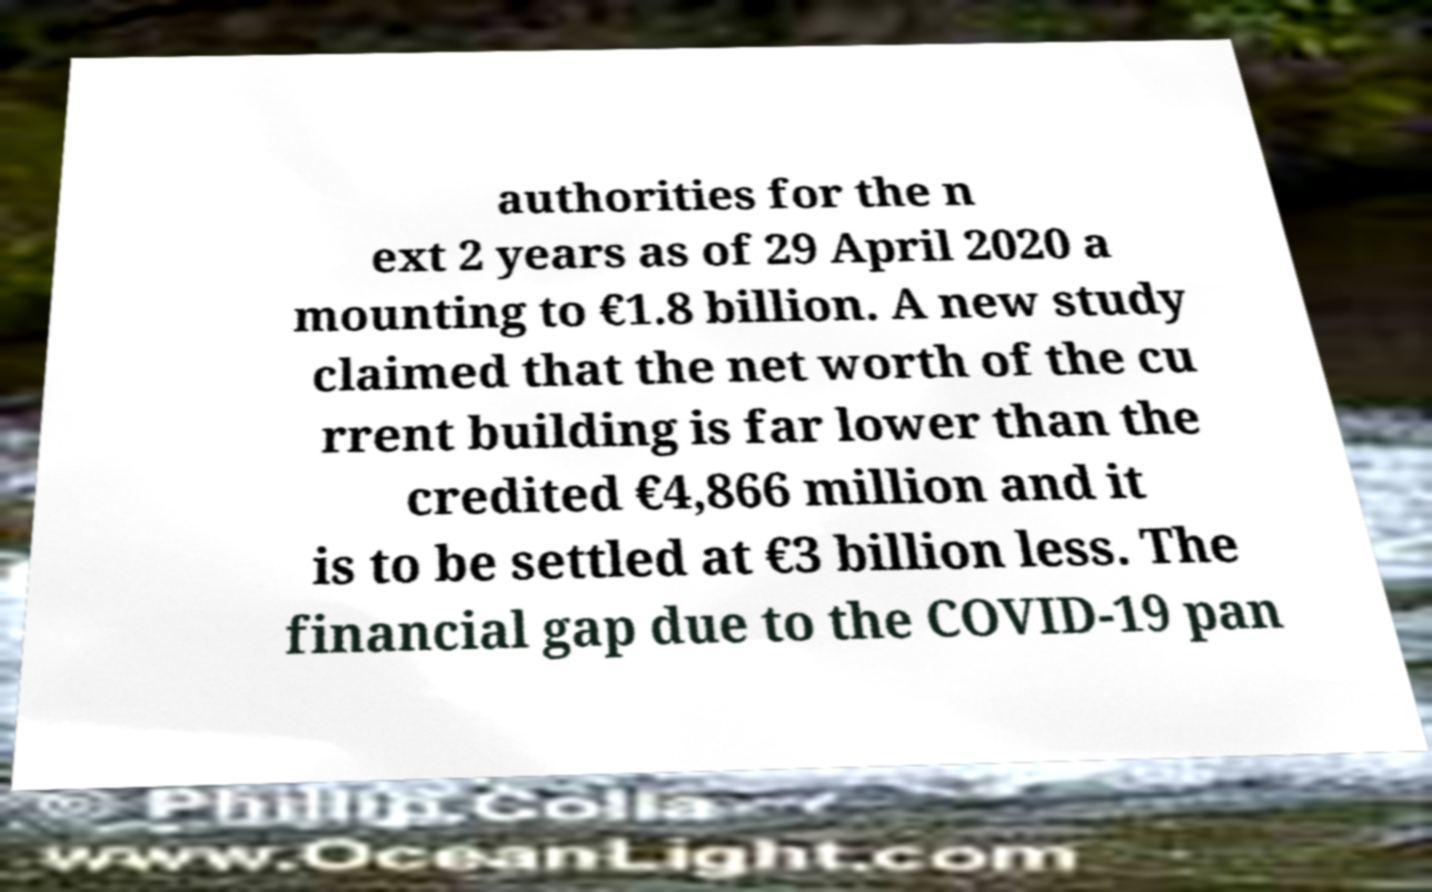What messages or text are displayed in this image? I need them in a readable, typed format. authorities for the n ext 2 years as of 29 April 2020 a mounting to €1.8 billion. A new study claimed that the net worth of the cu rrent building is far lower than the credited €4,866 million and it is to be settled at €3 billion less. The financial gap due to the COVID-19 pan 